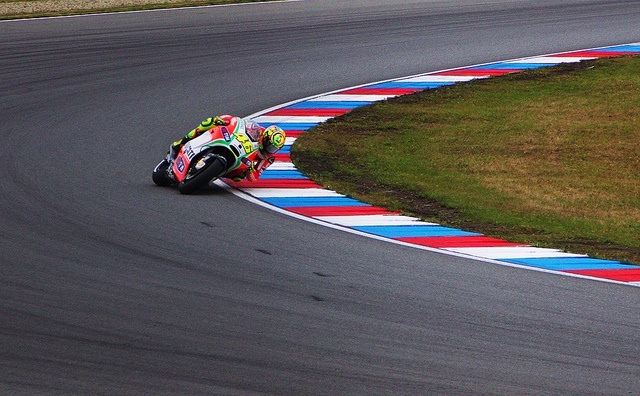Describe the objects in this image and their specific colors. I can see motorcycle in maroon, black, lightgray, darkgray, and red tones and people in maroon, black, gray, and brown tones in this image. 